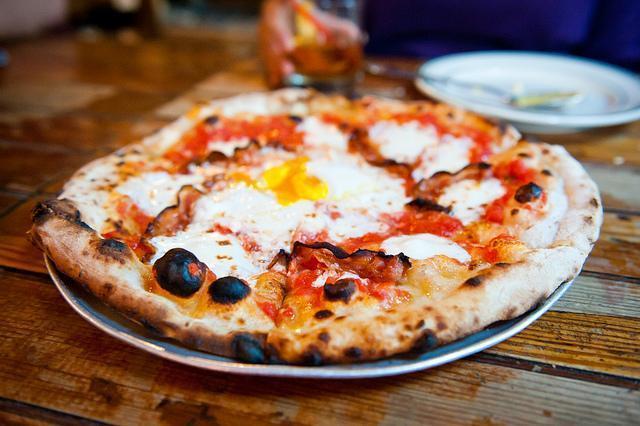How many pizzas are in the picture?
Give a very brief answer. 2. 